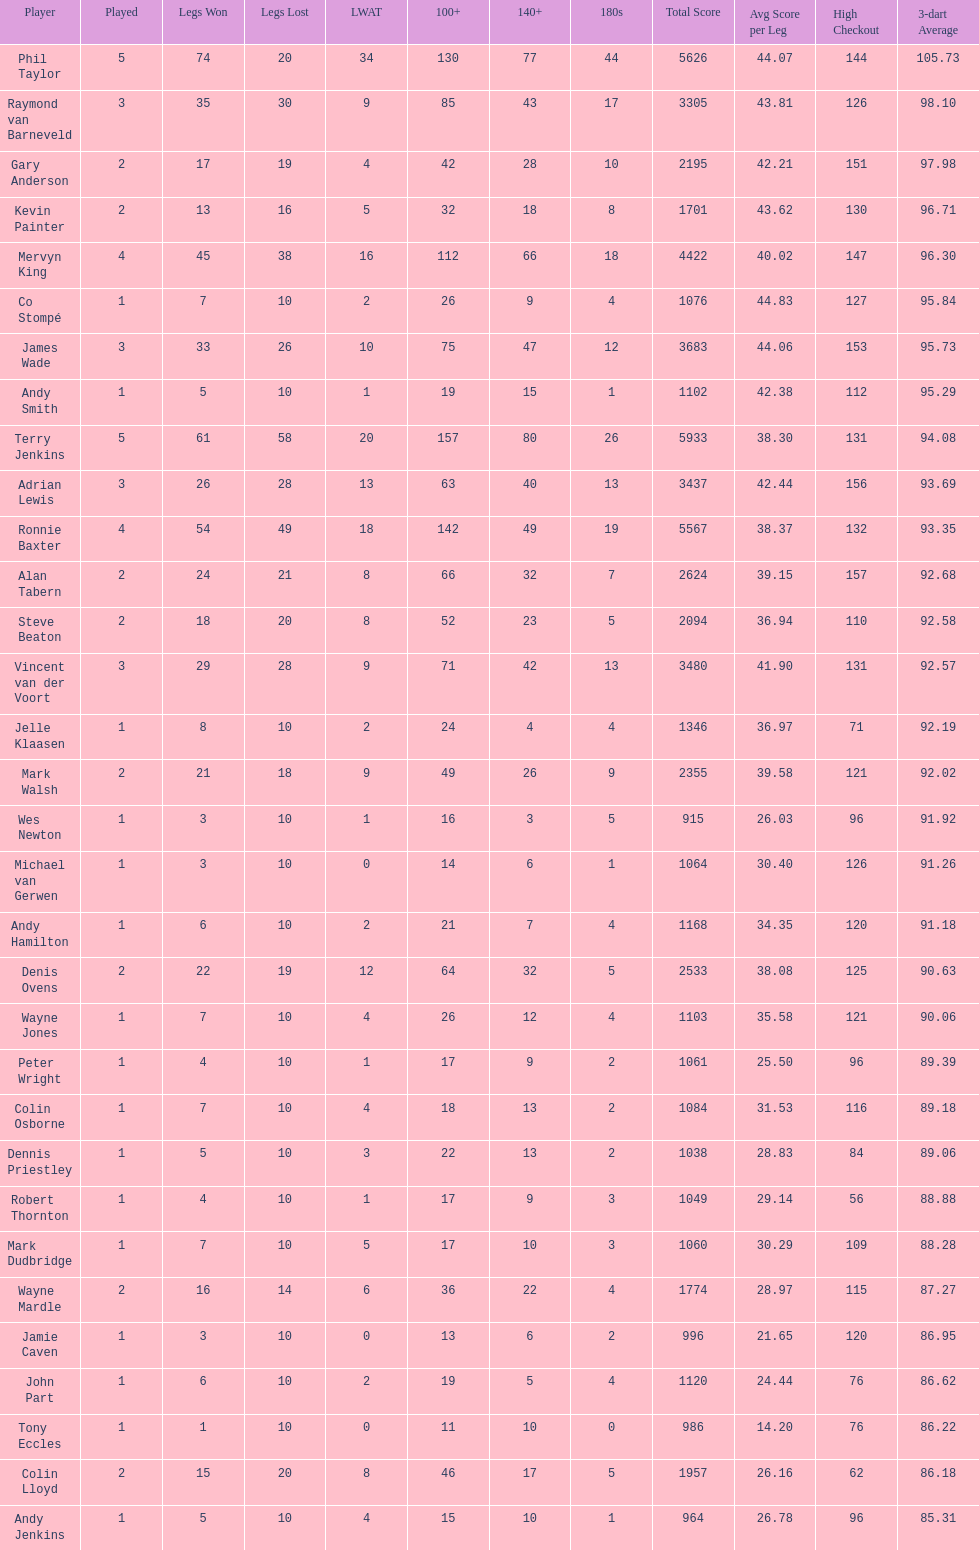Would you mind parsing the complete table? {'header': ['Player', 'Played', 'Legs Won', 'Legs Lost', 'LWAT', '100+', '140+', '180s', 'Total Score', 'Avg Score per Leg', 'High Checkout', '3-dart Average'], 'rows': [['Phil Taylor', '5', '74', '20', '34', '130', '77', '44', '5626', '44.07', '144', '105.73'], ['Raymond van Barneveld', '3', '35', '30', '9', '85', '43', '17', '3305', '43.81', '126', '98.10'], ['Gary Anderson', '2', '17', '19', '4', '42', '28', '10', '2195', '42.21', '151', '97.98'], ['Kevin Painter', '2', '13', '16', '5', '32', '18', '8', '1701', '43.62', '130', '96.71'], ['Mervyn King', '4', '45', '38', '16', '112', '66', '18', '4422', '40.02', '147', '96.30'], ['Co Stompé', '1', '7', '10', '2', '26', '9', '4', '1076', '44.83', '127', '95.84'], ['James Wade', '3', '33', '26', '10', '75', '47', '12', '3683', '44.06', '153', '95.73'], ['Andy Smith', '1', '5', '10', '1', '19', '15', '1', '1102', '42.38', '112', '95.29'], ['Terry Jenkins', '5', '61', '58', '20', '157', '80', '26', '5933', '38.30', '131', '94.08'], ['Adrian Lewis', '3', '26', '28', '13', '63', '40', '13', '3437', '42.44', '156', '93.69'], ['Ronnie Baxter', '4', '54', '49', '18', '142', '49', '19', '5567', '38.37', '132', '93.35'], ['Alan Tabern', '2', '24', '21', '8', '66', '32', '7', '2624', '39.15', '157', '92.68'], ['Steve Beaton', '2', '18', '20', '8', '52', '23', '5', '2094', '36.94', '110', '92.58'], ['Vincent van der Voort', '3', '29', '28', '9', '71', '42', '13', '3480', '41.90', '131', '92.57'], ['Jelle Klaasen', '1', '8', '10', '2', '24', '4', '4', '1346', '36.97', '71', '92.19'], ['Mark Walsh', '2', '21', '18', '9', '49', '26', '9', '2355', '39.58', '121', '92.02'], ['Wes Newton', '1', '3', '10', '1', '16', '3', '5', '915', '26.03', '96', '91.92'], ['Michael van Gerwen', '1', '3', '10', '0', '14', '6', '1', '1064', '30.40', '126', '91.26'], ['Andy Hamilton', '1', '6', '10', '2', '21', '7', '4', '1168', '34.35', '120', '91.18'], ['Denis Ovens', '2', '22', '19', '12', '64', '32', '5', '2533', '38.08', '125', '90.63'], ['Wayne Jones', '1', '7', '10', '4', '26', '12', '4', '1103', '35.58', '121', '90.06'], ['Peter Wright', '1', '4', '10', '1', '17', '9', '2', '1061', '25.50', '96', '89.39'], ['Colin Osborne', '1', '7', '10', '4', '18', '13', '2', '1084', '31.53', '116', '89.18'], ['Dennis Priestley', '1', '5', '10', '3', '22', '13', '2', '1038', '28.83', '84', '89.06'], ['Robert Thornton', '1', '4', '10', '1', '17', '9', '3', '1049', '29.14', '56', '88.88'], ['Mark Dudbridge', '1', '7', '10', '5', '17', '10', '3', '1060', '30.29', '109', '88.28'], ['Wayne Mardle', '2', '16', '14', '6', '36', '22', '4', '1774', '28.97', '115', '87.27'], ['Jamie Caven', '1', '3', '10', '0', '13', '6', '2', '996', '21.65', '120', '86.95'], ['John Part', '1', '6', '10', '2', '19', '5', '4', '1120', '24.44', '76', '86.62'], ['Tony Eccles', '1', '1', '10', '0', '11', '10', '0', '986', '14.20', '76', '86.22'], ['Colin Lloyd', '2', '15', '20', '8', '46', '17', '5', '1957', '26.16', '62', '86.18'], ['Andy Jenkins', '1', '5', '10', '4', '15', '10', '1', '964', '26.78', '96', '85.31']]} For andy smith or kevin painter, was their 3-dart average 9 Kevin Painter. 